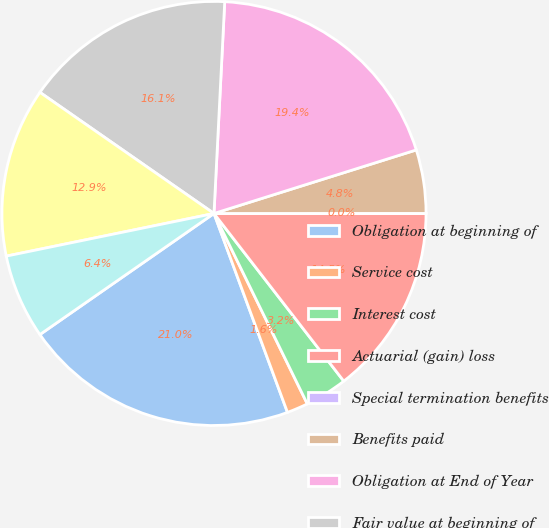Convert chart. <chart><loc_0><loc_0><loc_500><loc_500><pie_chart><fcel>Obligation at beginning of<fcel>Service cost<fcel>Interest cost<fcel>Actuarial (gain) loss<fcel>Special termination benefits<fcel>Benefits paid<fcel>Obligation at End of Year<fcel>Fair value at beginning of<fcel>Actual return on plan assets<fcel>Company contributions<nl><fcel>20.96%<fcel>1.62%<fcel>3.23%<fcel>14.51%<fcel>0.01%<fcel>4.84%<fcel>19.35%<fcel>16.13%<fcel>12.9%<fcel>6.45%<nl></chart> 